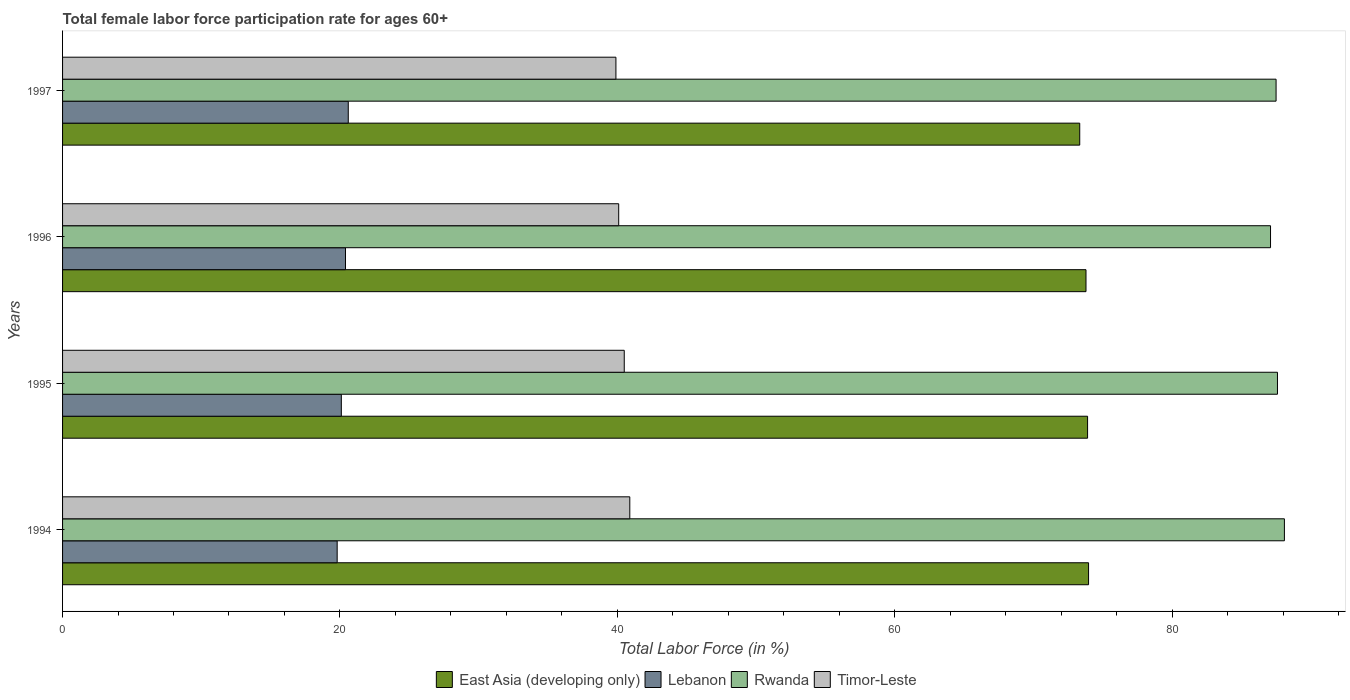How many different coloured bars are there?
Your response must be concise. 4. How many groups of bars are there?
Your answer should be compact. 4. Are the number of bars per tick equal to the number of legend labels?
Give a very brief answer. Yes. Are the number of bars on each tick of the Y-axis equal?
Give a very brief answer. Yes. How many bars are there on the 3rd tick from the top?
Your response must be concise. 4. What is the label of the 2nd group of bars from the top?
Your answer should be very brief. 1996. What is the female labor force participation rate in Timor-Leste in 1997?
Your answer should be compact. 39.9. Across all years, what is the maximum female labor force participation rate in Lebanon?
Your answer should be very brief. 20.6. Across all years, what is the minimum female labor force participation rate in Timor-Leste?
Give a very brief answer. 39.9. What is the total female labor force participation rate in Timor-Leste in the graph?
Offer a terse response. 161.4. What is the difference between the female labor force participation rate in East Asia (developing only) in 1994 and that in 1997?
Offer a terse response. 0.64. What is the difference between the female labor force participation rate in Timor-Leste in 1994 and the female labor force participation rate in East Asia (developing only) in 1997?
Make the answer very short. -32.44. What is the average female labor force participation rate in Rwanda per year?
Offer a very short reply. 87.57. In the year 1996, what is the difference between the female labor force participation rate in Lebanon and female labor force participation rate in Rwanda?
Keep it short and to the point. -66.7. What is the ratio of the female labor force participation rate in Lebanon in 1995 to that in 1997?
Offer a very short reply. 0.98. What is the difference between the highest and the second highest female labor force participation rate in Timor-Leste?
Provide a succinct answer. 0.4. What is the difference between the highest and the lowest female labor force participation rate in Timor-Leste?
Provide a succinct answer. 1. In how many years, is the female labor force participation rate in Timor-Leste greater than the average female labor force participation rate in Timor-Leste taken over all years?
Give a very brief answer. 2. Is the sum of the female labor force participation rate in East Asia (developing only) in 1994 and 1997 greater than the maximum female labor force participation rate in Lebanon across all years?
Your answer should be compact. Yes. What does the 1st bar from the top in 1994 represents?
Provide a succinct answer. Timor-Leste. What does the 3rd bar from the bottom in 1997 represents?
Your answer should be very brief. Rwanda. Is it the case that in every year, the sum of the female labor force participation rate in Timor-Leste and female labor force participation rate in Lebanon is greater than the female labor force participation rate in Rwanda?
Make the answer very short. No. How many years are there in the graph?
Provide a succinct answer. 4. What is the difference between two consecutive major ticks on the X-axis?
Keep it short and to the point. 20. Are the values on the major ticks of X-axis written in scientific E-notation?
Offer a very short reply. No. Does the graph contain grids?
Offer a very short reply. No. Where does the legend appear in the graph?
Your answer should be very brief. Bottom center. How are the legend labels stacked?
Offer a terse response. Horizontal. What is the title of the graph?
Offer a terse response. Total female labor force participation rate for ages 60+. What is the label or title of the X-axis?
Offer a very short reply. Total Labor Force (in %). What is the label or title of the Y-axis?
Your answer should be compact. Years. What is the Total Labor Force (in %) of East Asia (developing only) in 1994?
Make the answer very short. 73.98. What is the Total Labor Force (in %) in Lebanon in 1994?
Your answer should be compact. 19.8. What is the Total Labor Force (in %) in Rwanda in 1994?
Your answer should be compact. 88.1. What is the Total Labor Force (in %) of Timor-Leste in 1994?
Provide a succinct answer. 40.9. What is the Total Labor Force (in %) of East Asia (developing only) in 1995?
Offer a terse response. 73.91. What is the Total Labor Force (in %) of Lebanon in 1995?
Offer a terse response. 20.1. What is the Total Labor Force (in %) of Rwanda in 1995?
Provide a succinct answer. 87.6. What is the Total Labor Force (in %) in Timor-Leste in 1995?
Offer a very short reply. 40.5. What is the Total Labor Force (in %) in East Asia (developing only) in 1996?
Your answer should be very brief. 73.79. What is the Total Labor Force (in %) in Lebanon in 1996?
Give a very brief answer. 20.4. What is the Total Labor Force (in %) in Rwanda in 1996?
Provide a succinct answer. 87.1. What is the Total Labor Force (in %) of Timor-Leste in 1996?
Your answer should be very brief. 40.1. What is the Total Labor Force (in %) of East Asia (developing only) in 1997?
Provide a succinct answer. 73.34. What is the Total Labor Force (in %) in Lebanon in 1997?
Your answer should be compact. 20.6. What is the Total Labor Force (in %) of Rwanda in 1997?
Provide a succinct answer. 87.5. What is the Total Labor Force (in %) in Timor-Leste in 1997?
Offer a terse response. 39.9. Across all years, what is the maximum Total Labor Force (in %) in East Asia (developing only)?
Your answer should be very brief. 73.98. Across all years, what is the maximum Total Labor Force (in %) in Lebanon?
Your answer should be compact. 20.6. Across all years, what is the maximum Total Labor Force (in %) in Rwanda?
Offer a terse response. 88.1. Across all years, what is the maximum Total Labor Force (in %) in Timor-Leste?
Provide a short and direct response. 40.9. Across all years, what is the minimum Total Labor Force (in %) in East Asia (developing only)?
Provide a short and direct response. 73.34. Across all years, what is the minimum Total Labor Force (in %) in Lebanon?
Your response must be concise. 19.8. Across all years, what is the minimum Total Labor Force (in %) of Rwanda?
Offer a terse response. 87.1. Across all years, what is the minimum Total Labor Force (in %) in Timor-Leste?
Your response must be concise. 39.9. What is the total Total Labor Force (in %) in East Asia (developing only) in the graph?
Ensure brevity in your answer.  295.02. What is the total Total Labor Force (in %) in Lebanon in the graph?
Make the answer very short. 80.9. What is the total Total Labor Force (in %) of Rwanda in the graph?
Keep it short and to the point. 350.3. What is the total Total Labor Force (in %) in Timor-Leste in the graph?
Keep it short and to the point. 161.4. What is the difference between the Total Labor Force (in %) of East Asia (developing only) in 1994 and that in 1995?
Ensure brevity in your answer.  0.07. What is the difference between the Total Labor Force (in %) in Lebanon in 1994 and that in 1995?
Keep it short and to the point. -0.3. What is the difference between the Total Labor Force (in %) in Rwanda in 1994 and that in 1995?
Offer a terse response. 0.5. What is the difference between the Total Labor Force (in %) in East Asia (developing only) in 1994 and that in 1996?
Make the answer very short. 0.19. What is the difference between the Total Labor Force (in %) in Lebanon in 1994 and that in 1996?
Provide a succinct answer. -0.6. What is the difference between the Total Labor Force (in %) in Rwanda in 1994 and that in 1996?
Offer a very short reply. 1. What is the difference between the Total Labor Force (in %) of Timor-Leste in 1994 and that in 1996?
Ensure brevity in your answer.  0.8. What is the difference between the Total Labor Force (in %) of East Asia (developing only) in 1994 and that in 1997?
Keep it short and to the point. 0.64. What is the difference between the Total Labor Force (in %) in Lebanon in 1994 and that in 1997?
Keep it short and to the point. -0.8. What is the difference between the Total Labor Force (in %) of Rwanda in 1994 and that in 1997?
Provide a short and direct response. 0.6. What is the difference between the Total Labor Force (in %) of Timor-Leste in 1994 and that in 1997?
Keep it short and to the point. 1. What is the difference between the Total Labor Force (in %) of East Asia (developing only) in 1995 and that in 1996?
Your response must be concise. 0.11. What is the difference between the Total Labor Force (in %) in Lebanon in 1995 and that in 1996?
Your answer should be compact. -0.3. What is the difference between the Total Labor Force (in %) in Timor-Leste in 1995 and that in 1996?
Your answer should be compact. 0.4. What is the difference between the Total Labor Force (in %) of East Asia (developing only) in 1995 and that in 1997?
Provide a succinct answer. 0.57. What is the difference between the Total Labor Force (in %) in East Asia (developing only) in 1996 and that in 1997?
Your answer should be very brief. 0.45. What is the difference between the Total Labor Force (in %) in Rwanda in 1996 and that in 1997?
Your answer should be very brief. -0.4. What is the difference between the Total Labor Force (in %) of East Asia (developing only) in 1994 and the Total Labor Force (in %) of Lebanon in 1995?
Keep it short and to the point. 53.88. What is the difference between the Total Labor Force (in %) in East Asia (developing only) in 1994 and the Total Labor Force (in %) in Rwanda in 1995?
Your response must be concise. -13.62. What is the difference between the Total Labor Force (in %) of East Asia (developing only) in 1994 and the Total Labor Force (in %) of Timor-Leste in 1995?
Provide a succinct answer. 33.48. What is the difference between the Total Labor Force (in %) in Lebanon in 1994 and the Total Labor Force (in %) in Rwanda in 1995?
Your answer should be compact. -67.8. What is the difference between the Total Labor Force (in %) in Lebanon in 1994 and the Total Labor Force (in %) in Timor-Leste in 1995?
Make the answer very short. -20.7. What is the difference between the Total Labor Force (in %) in Rwanda in 1994 and the Total Labor Force (in %) in Timor-Leste in 1995?
Offer a very short reply. 47.6. What is the difference between the Total Labor Force (in %) of East Asia (developing only) in 1994 and the Total Labor Force (in %) of Lebanon in 1996?
Your answer should be very brief. 53.58. What is the difference between the Total Labor Force (in %) in East Asia (developing only) in 1994 and the Total Labor Force (in %) in Rwanda in 1996?
Offer a terse response. -13.12. What is the difference between the Total Labor Force (in %) of East Asia (developing only) in 1994 and the Total Labor Force (in %) of Timor-Leste in 1996?
Your answer should be compact. 33.88. What is the difference between the Total Labor Force (in %) in Lebanon in 1994 and the Total Labor Force (in %) in Rwanda in 1996?
Make the answer very short. -67.3. What is the difference between the Total Labor Force (in %) of Lebanon in 1994 and the Total Labor Force (in %) of Timor-Leste in 1996?
Your answer should be very brief. -20.3. What is the difference between the Total Labor Force (in %) of East Asia (developing only) in 1994 and the Total Labor Force (in %) of Lebanon in 1997?
Your response must be concise. 53.38. What is the difference between the Total Labor Force (in %) in East Asia (developing only) in 1994 and the Total Labor Force (in %) in Rwanda in 1997?
Your answer should be very brief. -13.52. What is the difference between the Total Labor Force (in %) in East Asia (developing only) in 1994 and the Total Labor Force (in %) in Timor-Leste in 1997?
Offer a terse response. 34.08. What is the difference between the Total Labor Force (in %) in Lebanon in 1994 and the Total Labor Force (in %) in Rwanda in 1997?
Your response must be concise. -67.7. What is the difference between the Total Labor Force (in %) in Lebanon in 1994 and the Total Labor Force (in %) in Timor-Leste in 1997?
Your answer should be very brief. -20.1. What is the difference between the Total Labor Force (in %) in Rwanda in 1994 and the Total Labor Force (in %) in Timor-Leste in 1997?
Offer a terse response. 48.2. What is the difference between the Total Labor Force (in %) of East Asia (developing only) in 1995 and the Total Labor Force (in %) of Lebanon in 1996?
Give a very brief answer. 53.51. What is the difference between the Total Labor Force (in %) of East Asia (developing only) in 1995 and the Total Labor Force (in %) of Rwanda in 1996?
Offer a terse response. -13.19. What is the difference between the Total Labor Force (in %) of East Asia (developing only) in 1995 and the Total Labor Force (in %) of Timor-Leste in 1996?
Your answer should be compact. 33.81. What is the difference between the Total Labor Force (in %) in Lebanon in 1995 and the Total Labor Force (in %) in Rwanda in 1996?
Your answer should be compact. -67. What is the difference between the Total Labor Force (in %) of Rwanda in 1995 and the Total Labor Force (in %) of Timor-Leste in 1996?
Offer a terse response. 47.5. What is the difference between the Total Labor Force (in %) in East Asia (developing only) in 1995 and the Total Labor Force (in %) in Lebanon in 1997?
Offer a very short reply. 53.31. What is the difference between the Total Labor Force (in %) in East Asia (developing only) in 1995 and the Total Labor Force (in %) in Rwanda in 1997?
Provide a succinct answer. -13.59. What is the difference between the Total Labor Force (in %) of East Asia (developing only) in 1995 and the Total Labor Force (in %) of Timor-Leste in 1997?
Offer a terse response. 34.01. What is the difference between the Total Labor Force (in %) of Lebanon in 1995 and the Total Labor Force (in %) of Rwanda in 1997?
Offer a terse response. -67.4. What is the difference between the Total Labor Force (in %) in Lebanon in 1995 and the Total Labor Force (in %) in Timor-Leste in 1997?
Ensure brevity in your answer.  -19.8. What is the difference between the Total Labor Force (in %) in Rwanda in 1995 and the Total Labor Force (in %) in Timor-Leste in 1997?
Ensure brevity in your answer.  47.7. What is the difference between the Total Labor Force (in %) in East Asia (developing only) in 1996 and the Total Labor Force (in %) in Lebanon in 1997?
Provide a succinct answer. 53.19. What is the difference between the Total Labor Force (in %) in East Asia (developing only) in 1996 and the Total Labor Force (in %) in Rwanda in 1997?
Your response must be concise. -13.71. What is the difference between the Total Labor Force (in %) of East Asia (developing only) in 1996 and the Total Labor Force (in %) of Timor-Leste in 1997?
Your response must be concise. 33.89. What is the difference between the Total Labor Force (in %) in Lebanon in 1996 and the Total Labor Force (in %) in Rwanda in 1997?
Ensure brevity in your answer.  -67.1. What is the difference between the Total Labor Force (in %) in Lebanon in 1996 and the Total Labor Force (in %) in Timor-Leste in 1997?
Give a very brief answer. -19.5. What is the difference between the Total Labor Force (in %) in Rwanda in 1996 and the Total Labor Force (in %) in Timor-Leste in 1997?
Provide a succinct answer. 47.2. What is the average Total Labor Force (in %) of East Asia (developing only) per year?
Provide a short and direct response. 73.76. What is the average Total Labor Force (in %) of Lebanon per year?
Your response must be concise. 20.23. What is the average Total Labor Force (in %) in Rwanda per year?
Your answer should be very brief. 87.58. What is the average Total Labor Force (in %) in Timor-Leste per year?
Give a very brief answer. 40.35. In the year 1994, what is the difference between the Total Labor Force (in %) of East Asia (developing only) and Total Labor Force (in %) of Lebanon?
Make the answer very short. 54.18. In the year 1994, what is the difference between the Total Labor Force (in %) in East Asia (developing only) and Total Labor Force (in %) in Rwanda?
Your answer should be compact. -14.12. In the year 1994, what is the difference between the Total Labor Force (in %) of East Asia (developing only) and Total Labor Force (in %) of Timor-Leste?
Provide a short and direct response. 33.08. In the year 1994, what is the difference between the Total Labor Force (in %) of Lebanon and Total Labor Force (in %) of Rwanda?
Offer a very short reply. -68.3. In the year 1994, what is the difference between the Total Labor Force (in %) in Lebanon and Total Labor Force (in %) in Timor-Leste?
Ensure brevity in your answer.  -21.1. In the year 1994, what is the difference between the Total Labor Force (in %) of Rwanda and Total Labor Force (in %) of Timor-Leste?
Give a very brief answer. 47.2. In the year 1995, what is the difference between the Total Labor Force (in %) of East Asia (developing only) and Total Labor Force (in %) of Lebanon?
Your answer should be compact. 53.81. In the year 1995, what is the difference between the Total Labor Force (in %) in East Asia (developing only) and Total Labor Force (in %) in Rwanda?
Provide a short and direct response. -13.69. In the year 1995, what is the difference between the Total Labor Force (in %) in East Asia (developing only) and Total Labor Force (in %) in Timor-Leste?
Keep it short and to the point. 33.41. In the year 1995, what is the difference between the Total Labor Force (in %) in Lebanon and Total Labor Force (in %) in Rwanda?
Your response must be concise. -67.5. In the year 1995, what is the difference between the Total Labor Force (in %) of Lebanon and Total Labor Force (in %) of Timor-Leste?
Provide a short and direct response. -20.4. In the year 1995, what is the difference between the Total Labor Force (in %) in Rwanda and Total Labor Force (in %) in Timor-Leste?
Your answer should be very brief. 47.1. In the year 1996, what is the difference between the Total Labor Force (in %) in East Asia (developing only) and Total Labor Force (in %) in Lebanon?
Make the answer very short. 53.39. In the year 1996, what is the difference between the Total Labor Force (in %) in East Asia (developing only) and Total Labor Force (in %) in Rwanda?
Ensure brevity in your answer.  -13.31. In the year 1996, what is the difference between the Total Labor Force (in %) of East Asia (developing only) and Total Labor Force (in %) of Timor-Leste?
Offer a very short reply. 33.69. In the year 1996, what is the difference between the Total Labor Force (in %) of Lebanon and Total Labor Force (in %) of Rwanda?
Make the answer very short. -66.7. In the year 1996, what is the difference between the Total Labor Force (in %) of Lebanon and Total Labor Force (in %) of Timor-Leste?
Provide a succinct answer. -19.7. In the year 1997, what is the difference between the Total Labor Force (in %) of East Asia (developing only) and Total Labor Force (in %) of Lebanon?
Ensure brevity in your answer.  52.74. In the year 1997, what is the difference between the Total Labor Force (in %) of East Asia (developing only) and Total Labor Force (in %) of Rwanda?
Give a very brief answer. -14.16. In the year 1997, what is the difference between the Total Labor Force (in %) in East Asia (developing only) and Total Labor Force (in %) in Timor-Leste?
Give a very brief answer. 33.44. In the year 1997, what is the difference between the Total Labor Force (in %) of Lebanon and Total Labor Force (in %) of Rwanda?
Keep it short and to the point. -66.9. In the year 1997, what is the difference between the Total Labor Force (in %) of Lebanon and Total Labor Force (in %) of Timor-Leste?
Offer a terse response. -19.3. In the year 1997, what is the difference between the Total Labor Force (in %) in Rwanda and Total Labor Force (in %) in Timor-Leste?
Provide a succinct answer. 47.6. What is the ratio of the Total Labor Force (in %) in Lebanon in 1994 to that in 1995?
Make the answer very short. 0.99. What is the ratio of the Total Labor Force (in %) of Timor-Leste in 1994 to that in 1995?
Provide a short and direct response. 1.01. What is the ratio of the Total Labor Force (in %) of East Asia (developing only) in 1994 to that in 1996?
Make the answer very short. 1. What is the ratio of the Total Labor Force (in %) of Lebanon in 1994 to that in 1996?
Make the answer very short. 0.97. What is the ratio of the Total Labor Force (in %) of Rwanda in 1994 to that in 1996?
Provide a succinct answer. 1.01. What is the ratio of the Total Labor Force (in %) in East Asia (developing only) in 1994 to that in 1997?
Make the answer very short. 1.01. What is the ratio of the Total Labor Force (in %) of Lebanon in 1994 to that in 1997?
Provide a short and direct response. 0.96. What is the ratio of the Total Labor Force (in %) in Timor-Leste in 1994 to that in 1997?
Keep it short and to the point. 1.03. What is the ratio of the Total Labor Force (in %) of East Asia (developing only) in 1995 to that in 1996?
Give a very brief answer. 1. What is the ratio of the Total Labor Force (in %) in Rwanda in 1995 to that in 1996?
Your response must be concise. 1.01. What is the ratio of the Total Labor Force (in %) of East Asia (developing only) in 1995 to that in 1997?
Ensure brevity in your answer.  1.01. What is the ratio of the Total Labor Force (in %) in Lebanon in 1995 to that in 1997?
Ensure brevity in your answer.  0.98. What is the ratio of the Total Labor Force (in %) in Timor-Leste in 1995 to that in 1997?
Offer a very short reply. 1.01. What is the ratio of the Total Labor Force (in %) of East Asia (developing only) in 1996 to that in 1997?
Offer a very short reply. 1.01. What is the ratio of the Total Labor Force (in %) in Lebanon in 1996 to that in 1997?
Your answer should be compact. 0.99. What is the difference between the highest and the second highest Total Labor Force (in %) of East Asia (developing only)?
Your answer should be compact. 0.07. What is the difference between the highest and the second highest Total Labor Force (in %) in Rwanda?
Your answer should be very brief. 0.5. What is the difference between the highest and the lowest Total Labor Force (in %) of East Asia (developing only)?
Ensure brevity in your answer.  0.64. What is the difference between the highest and the lowest Total Labor Force (in %) in Lebanon?
Offer a very short reply. 0.8. What is the difference between the highest and the lowest Total Labor Force (in %) in Rwanda?
Offer a terse response. 1. What is the difference between the highest and the lowest Total Labor Force (in %) in Timor-Leste?
Your answer should be compact. 1. 